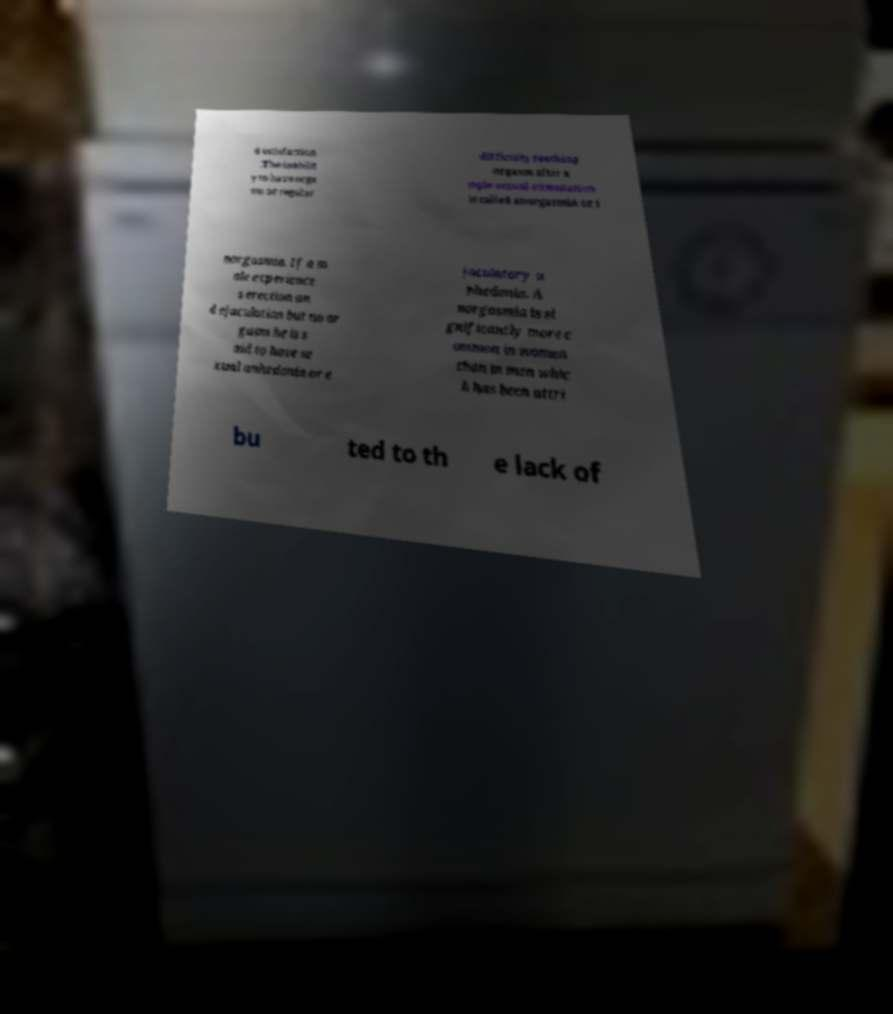I need the written content from this picture converted into text. Can you do that? d satisfaction .The inabilit y to have orga sm or regular difficulty reaching orgasm after a mple sexual stimulation is called anorgasmia or i norgasmia. If a m ale experience s erection an d ejaculation but no or gasm he is s aid to have se xual anhedonia or e jaculatory a nhedonia. A norgasmia is si gnificantly more c ommon in women than in men whic h has been attri bu ted to th e lack of 